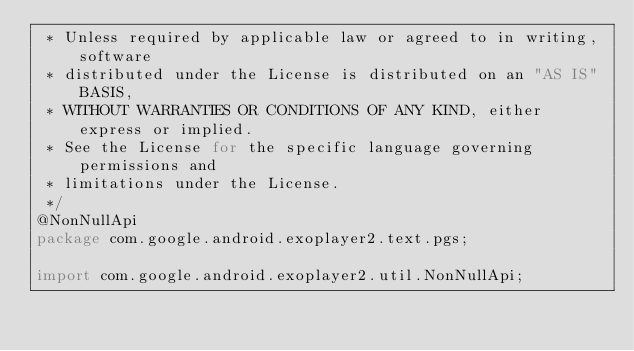Convert code to text. <code><loc_0><loc_0><loc_500><loc_500><_Java_> * Unless required by applicable law or agreed to in writing, software
 * distributed under the License is distributed on an "AS IS" BASIS,
 * WITHOUT WARRANTIES OR CONDITIONS OF ANY KIND, either express or implied.
 * See the License for the specific language governing permissions and
 * limitations under the License.
 */
@NonNullApi
package com.google.android.exoplayer2.text.pgs;

import com.google.android.exoplayer2.util.NonNullApi;
</code> 